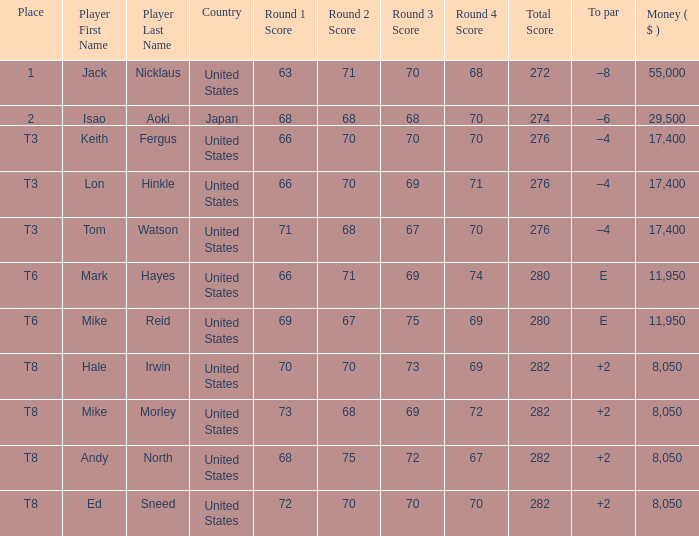What to par is located in the united states and has the player by the name of hale irwin? 2.0. 